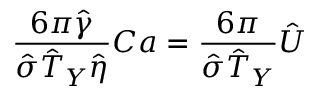<formula> <loc_0><loc_0><loc_500><loc_500>\frac { 6 \pi \hat { \gamma } } { \hat { \sigma } \hat { T } _ { Y } \hat { \eta } } C a = \frac { 6 \pi } { \hat { \sigma } \hat { T } _ { Y } } \hat { U }</formula> 